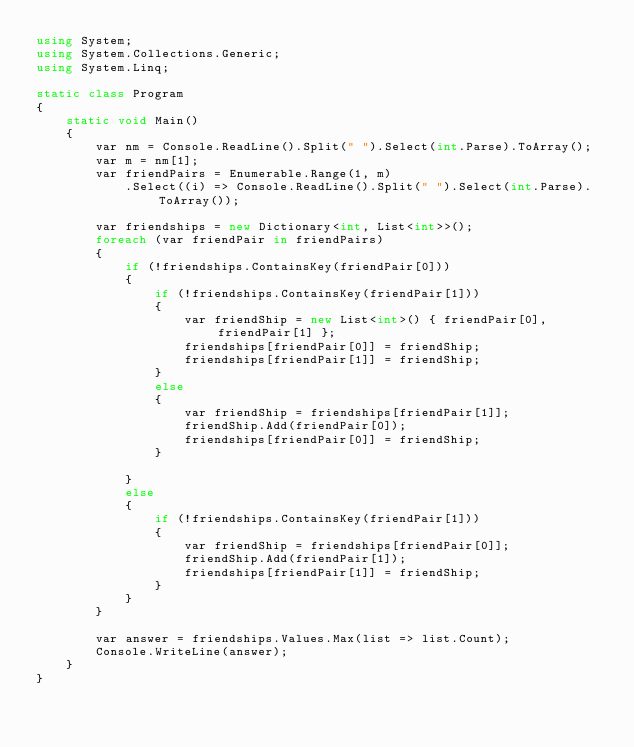<code> <loc_0><loc_0><loc_500><loc_500><_C#_>using System;
using System.Collections.Generic;
using System.Linq;

static class Program
{
    static void Main()
    {
        var nm = Console.ReadLine().Split(" ").Select(int.Parse).ToArray();
        var m = nm[1];
        var friendPairs = Enumerable.Range(1, m)
            .Select((i) => Console.ReadLine().Split(" ").Select(int.Parse).ToArray());

        var friendships = new Dictionary<int, List<int>>();
        foreach (var friendPair in friendPairs)
        {
            if (!friendships.ContainsKey(friendPair[0]))
            {
                if (!friendships.ContainsKey(friendPair[1]))
                {
                    var friendShip = new List<int>() { friendPair[0], friendPair[1] };
                    friendships[friendPair[0]] = friendShip;
                    friendships[friendPair[1]] = friendShip;
                }
                else
                {
                    var friendShip = friendships[friendPair[1]];
                    friendShip.Add(friendPair[0]);
                    friendships[friendPair[0]] = friendShip;
                }

            }
            else
            {
                if (!friendships.ContainsKey(friendPair[1]))
                {
                    var friendShip = friendships[friendPair[0]];
                    friendShip.Add(friendPair[1]);
                    friendships[friendPair[1]] = friendShip;
                }
            }
        }

        var answer = friendships.Values.Max(list => list.Count);
        Console.WriteLine(answer);
    }
}</code> 